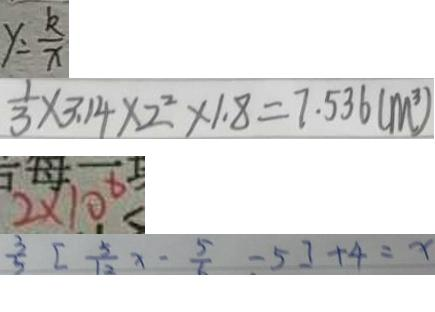Convert formula to latex. <formula><loc_0><loc_0><loc_500><loc_500>y = \frac { k } { x } 
 \frac { 1 } { 3 } \times 3 . 1 4 \times 2 ^ { 2 } \times 1 . 8 = 7 . 5 3 6 ( m ^ { 3 } ) 
 2 \times 1 0 ^ { 6 } 
 \frac { 3 } { 5 } [ \frac { 5 } { 1 2 } x - \frac { 5 } { 6 } - 5 ] + 4 = x</formula> 